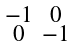<formula> <loc_0><loc_0><loc_500><loc_500>\begin{smallmatrix} - 1 & 0 \\ 0 & - 1 \\ \end{smallmatrix}</formula> 